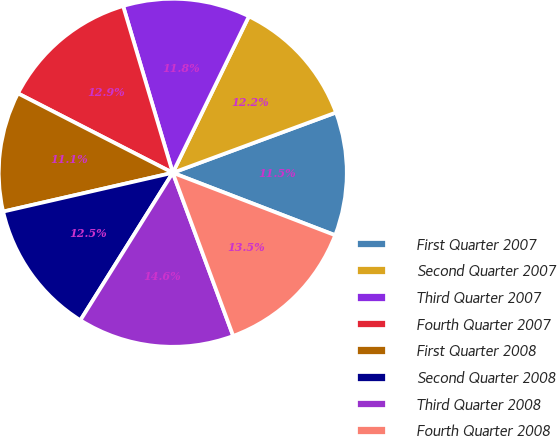<chart> <loc_0><loc_0><loc_500><loc_500><pie_chart><fcel>First Quarter 2007<fcel>Second Quarter 2007<fcel>Third Quarter 2007<fcel>Fourth Quarter 2007<fcel>First Quarter 2008<fcel>Second Quarter 2008<fcel>Third Quarter 2008<fcel>Fourth Quarter 2008<nl><fcel>11.47%<fcel>12.16%<fcel>11.81%<fcel>12.85%<fcel>11.12%<fcel>12.51%<fcel>14.55%<fcel>13.51%<nl></chart> 